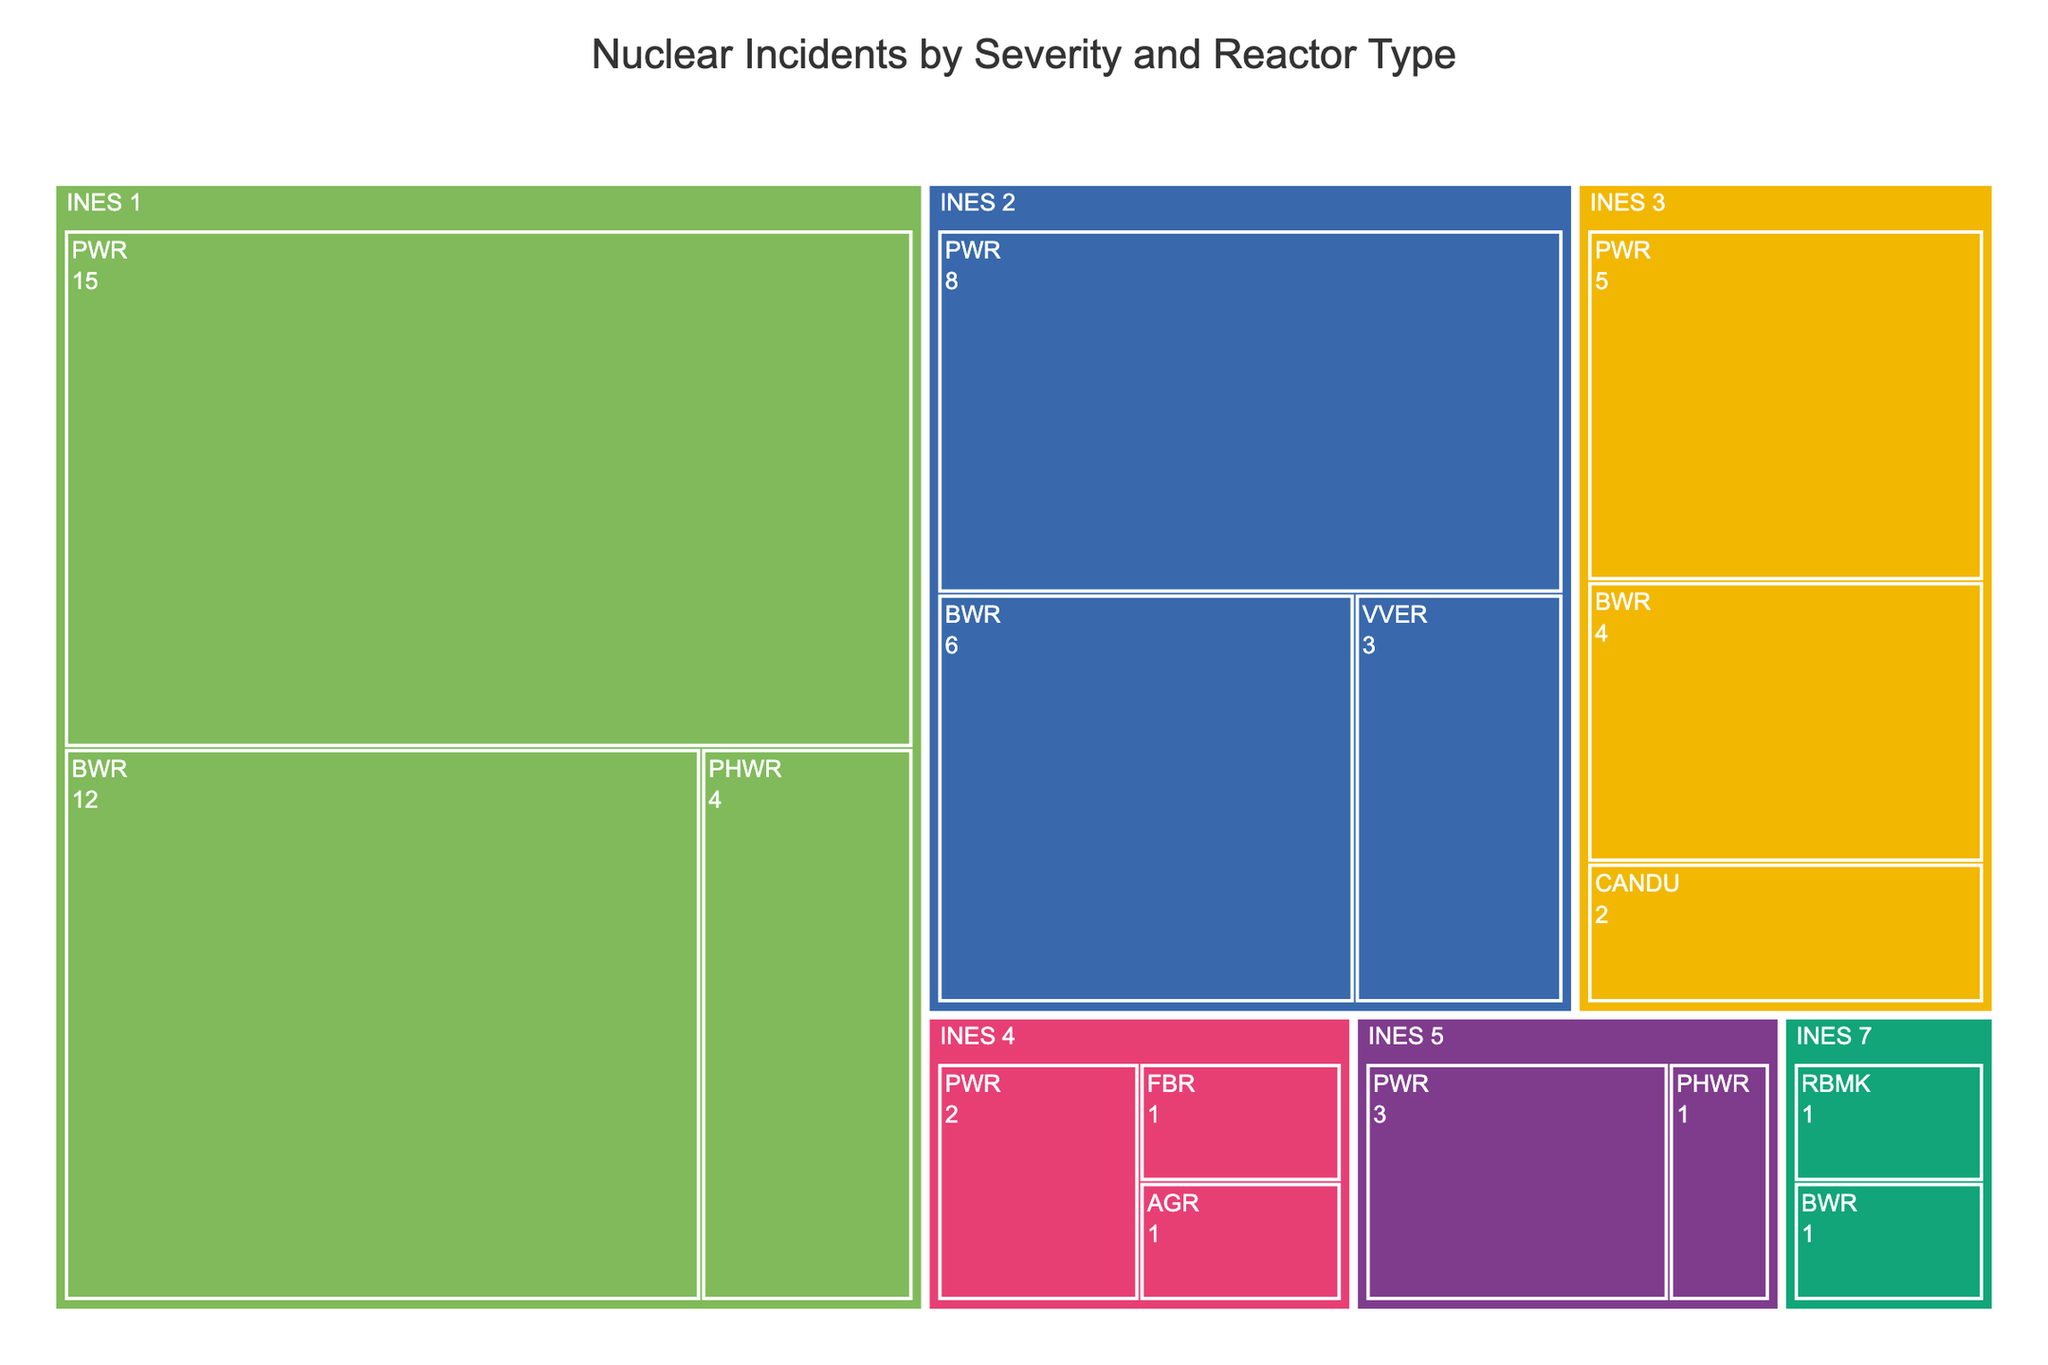What's the title of the chart? The title of the chart is usually displayed prominently at the top of the figure. It's typically a brief description that provides an overview of what the chart depicts.
Answer: Nuclear Incidents by Severity and Reactor Type Which reactor type has the highest number of incidents recorded for INES 1 severity? Look for the INES 1 severity category and find the reactor type with the largest incident count.
Answer: PWR How many incidents were recorded for the INES 2 severity level? Sum the incident counts from all reactor types within the INES 2 severity category. This includes PWR, BWR, and VVER reactor types.
Answer: 17 Which severity level and reactor type combination had exactly one incident? Identify all combinations and count the incidents for each. The combinations to look at are INES 7 with RBMK, INES 7 with BWR, INES 5 with PHWR, INES 4 with AGR, and INES 4 with FBR.
Answer: INES 7 with RBMK, INES 7 with BWR, INES 5 with PHWR, INES 4 with AGR, INES 4 with FBR Compare the number of incidents recorded for BWR reactors between INES 1 and INES 2 severities. Locate the BWR reactor type under INES 1 and INES 2 severities and compare their incident counts.
Answer: INES 1 has 12 incidents, while INES 2 has 6 incidents Which severity level has the greatest diversity in reactor types? Count the number of unique reactor types for each severity level. The severity with the most unique reactor types has the greatest diversity.
Answer: INES 1 What is the most common reactor type across all severity levels? Sum the incident counts for each reactor type across all severity levels and identify the reactor type with the highest total incidents.
Answer: PWR How many incidents do RBMK reactors have across all severity levels? Add up the incidents involving RBMK reactors at all severity levels. The only entry is under INES 7.
Answer: 1 Which two reactor types have the same total number of incidents when comparing INES 1 and INES 3 severities? Compare the incident counts for each reactor type between INES 1 and INES 3. Match reactor types with equal totals.
Answer: CANDU and PHWR both have 2 incidents What is the overall trend of incident counts from highest to lowest severity level? Observe the count and distribution of incidents starting from INES 7 down to INES 1. Note if the incident counts are increasing, decreasing, or inconsistent.
Answer: Generally decreases from higher to lower severity levels 